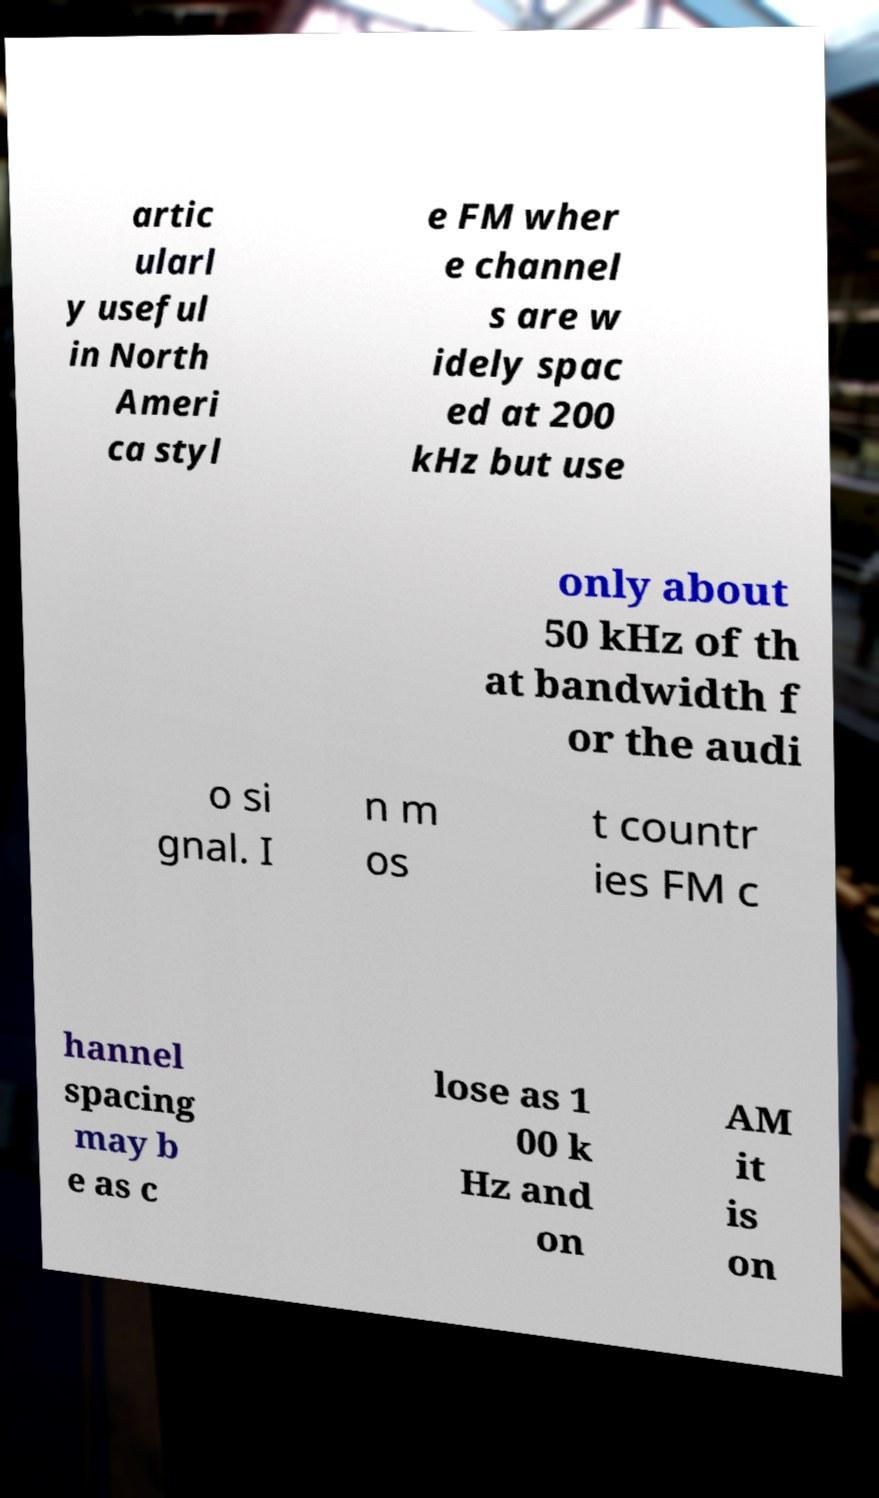For documentation purposes, I need the text within this image transcribed. Could you provide that? artic ularl y useful in North Ameri ca styl e FM wher e channel s are w idely spac ed at 200 kHz but use only about 50 kHz of th at bandwidth f or the audi o si gnal. I n m os t countr ies FM c hannel spacing may b e as c lose as 1 00 k Hz and on AM it is on 